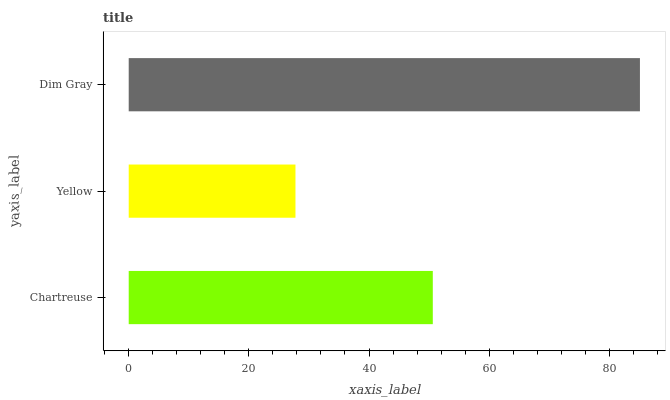Is Yellow the minimum?
Answer yes or no. Yes. Is Dim Gray the maximum?
Answer yes or no. Yes. Is Dim Gray the minimum?
Answer yes or no. No. Is Yellow the maximum?
Answer yes or no. No. Is Dim Gray greater than Yellow?
Answer yes or no. Yes. Is Yellow less than Dim Gray?
Answer yes or no. Yes. Is Yellow greater than Dim Gray?
Answer yes or no. No. Is Dim Gray less than Yellow?
Answer yes or no. No. Is Chartreuse the high median?
Answer yes or no. Yes. Is Chartreuse the low median?
Answer yes or no. Yes. Is Dim Gray the high median?
Answer yes or no. No. Is Dim Gray the low median?
Answer yes or no. No. 